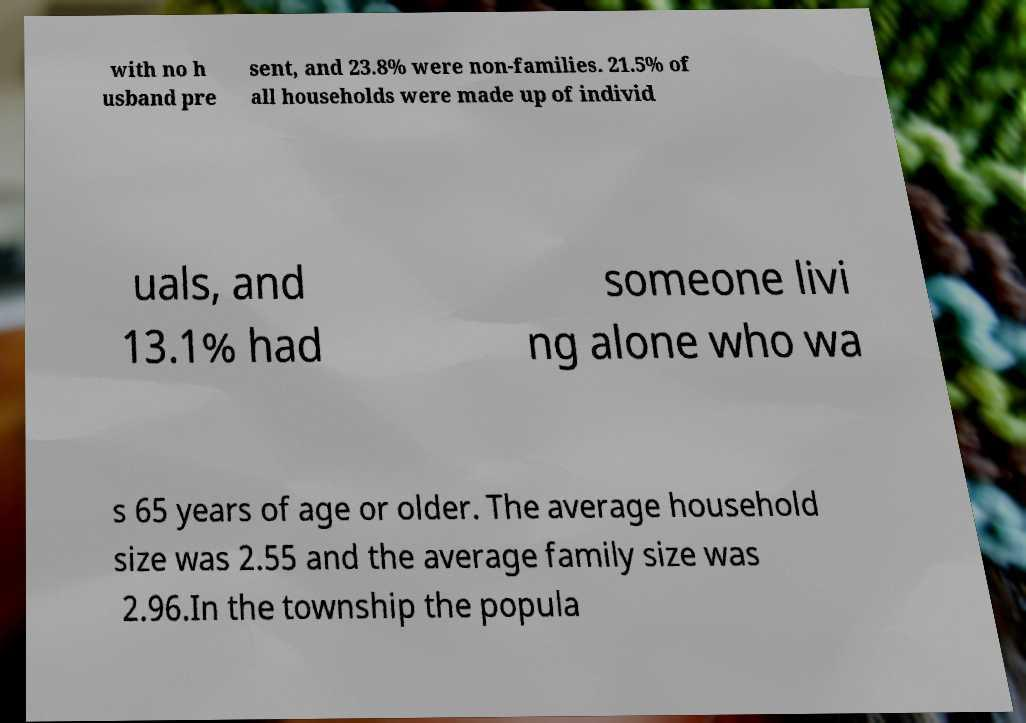There's text embedded in this image that I need extracted. Can you transcribe it verbatim? with no h usband pre sent, and 23.8% were non-families. 21.5% of all households were made up of individ uals, and 13.1% had someone livi ng alone who wa s 65 years of age or older. The average household size was 2.55 and the average family size was 2.96.In the township the popula 